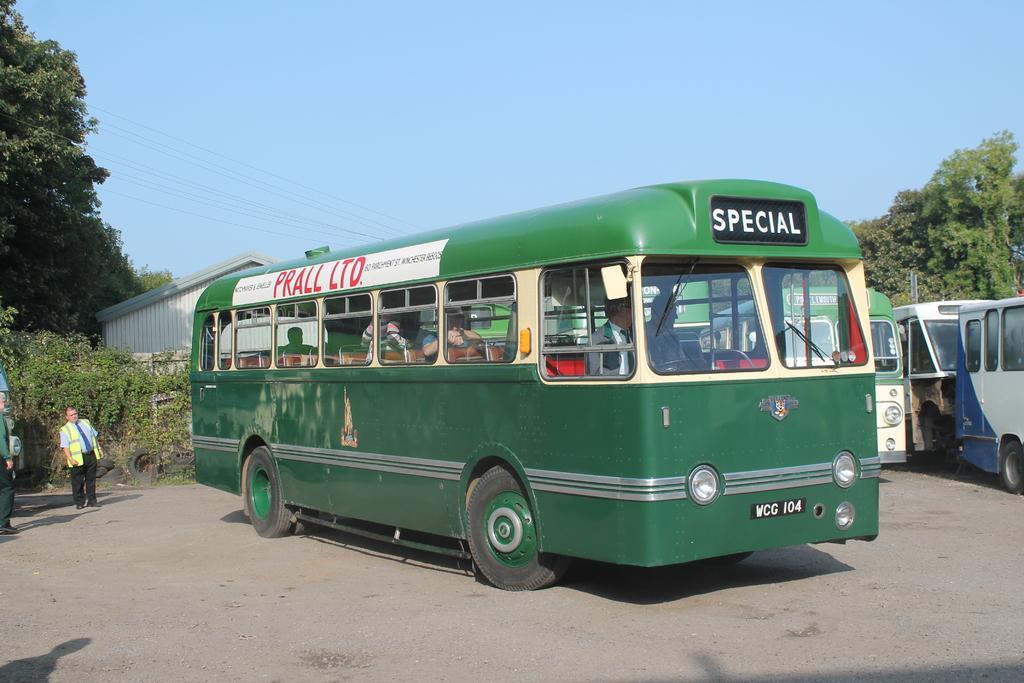Describe this image in one or two sentences. In this image there are people sitting inside the bus. Beside the bus there are a few other buses on the road. On the left side of the image there are two people. In the background of the image there is a wall. There is a building. There are trees and sky. 